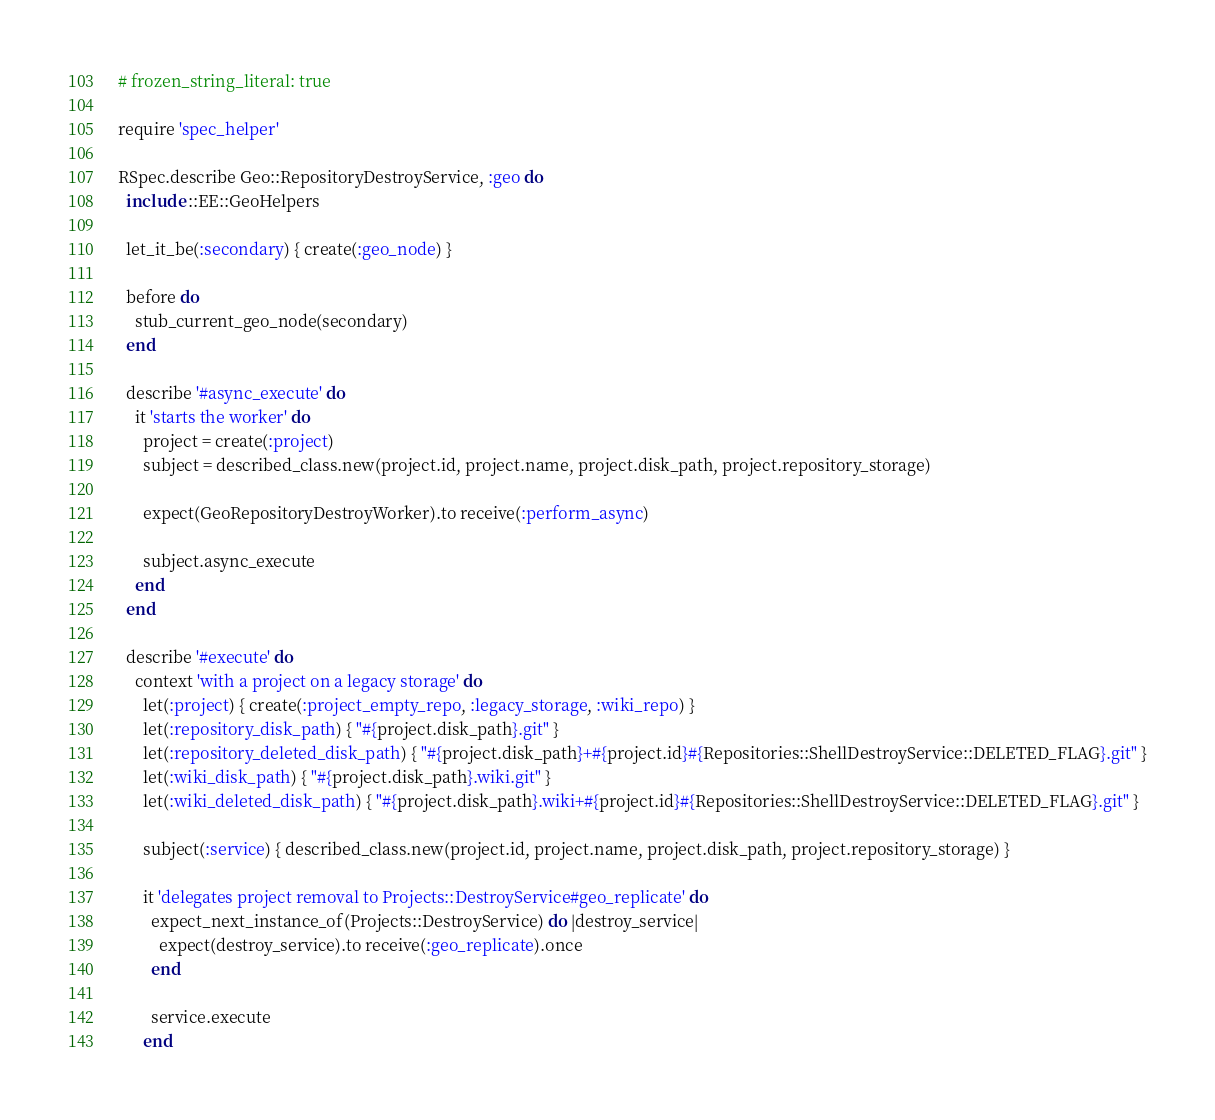<code> <loc_0><loc_0><loc_500><loc_500><_Ruby_># frozen_string_literal: true

require 'spec_helper'

RSpec.describe Geo::RepositoryDestroyService, :geo do
  include ::EE::GeoHelpers

  let_it_be(:secondary) { create(:geo_node) }

  before do
    stub_current_geo_node(secondary)
  end

  describe '#async_execute' do
    it 'starts the worker' do
      project = create(:project)
      subject = described_class.new(project.id, project.name, project.disk_path, project.repository_storage)

      expect(GeoRepositoryDestroyWorker).to receive(:perform_async)

      subject.async_execute
    end
  end

  describe '#execute' do
    context 'with a project on a legacy storage' do
      let(:project) { create(:project_empty_repo, :legacy_storage, :wiki_repo) }
      let(:repository_disk_path) { "#{project.disk_path}.git" }
      let(:repository_deleted_disk_path) { "#{project.disk_path}+#{project.id}#{Repositories::ShellDestroyService::DELETED_FLAG}.git" }
      let(:wiki_disk_path) { "#{project.disk_path}.wiki.git" }
      let(:wiki_deleted_disk_path) { "#{project.disk_path}.wiki+#{project.id}#{Repositories::ShellDestroyService::DELETED_FLAG}.git" }

      subject(:service) { described_class.new(project.id, project.name, project.disk_path, project.repository_storage) }

      it 'delegates project removal to Projects::DestroyService#geo_replicate' do
        expect_next_instance_of(Projects::DestroyService) do |destroy_service|
          expect(destroy_service).to receive(:geo_replicate).once
        end

        service.execute
      end
</code> 